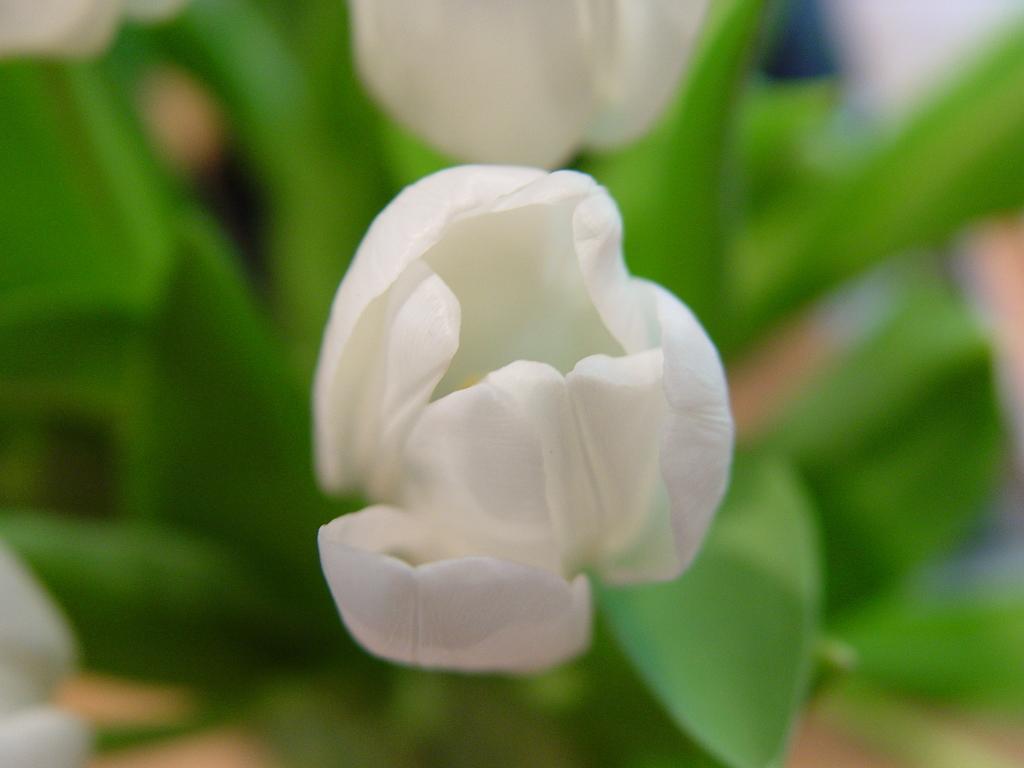In one or two sentences, can you explain what this image depicts? In this image, we can see a flower and the background is blurred. 